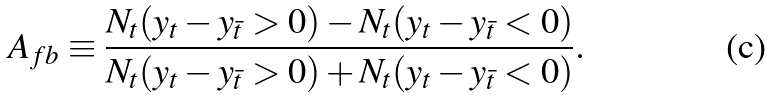<formula> <loc_0><loc_0><loc_500><loc_500>A _ { f b } \equiv \frac { N _ { t } ( y _ { t } - y _ { \bar { t } } > 0 ) - N _ { t } ( y _ { t } - y _ { \bar { t } } < 0 ) } { N _ { t } ( y _ { t } - y _ { \bar { t } } > 0 ) + N _ { t } ( y _ { t } - y _ { \bar { t } } < 0 ) } .</formula> 